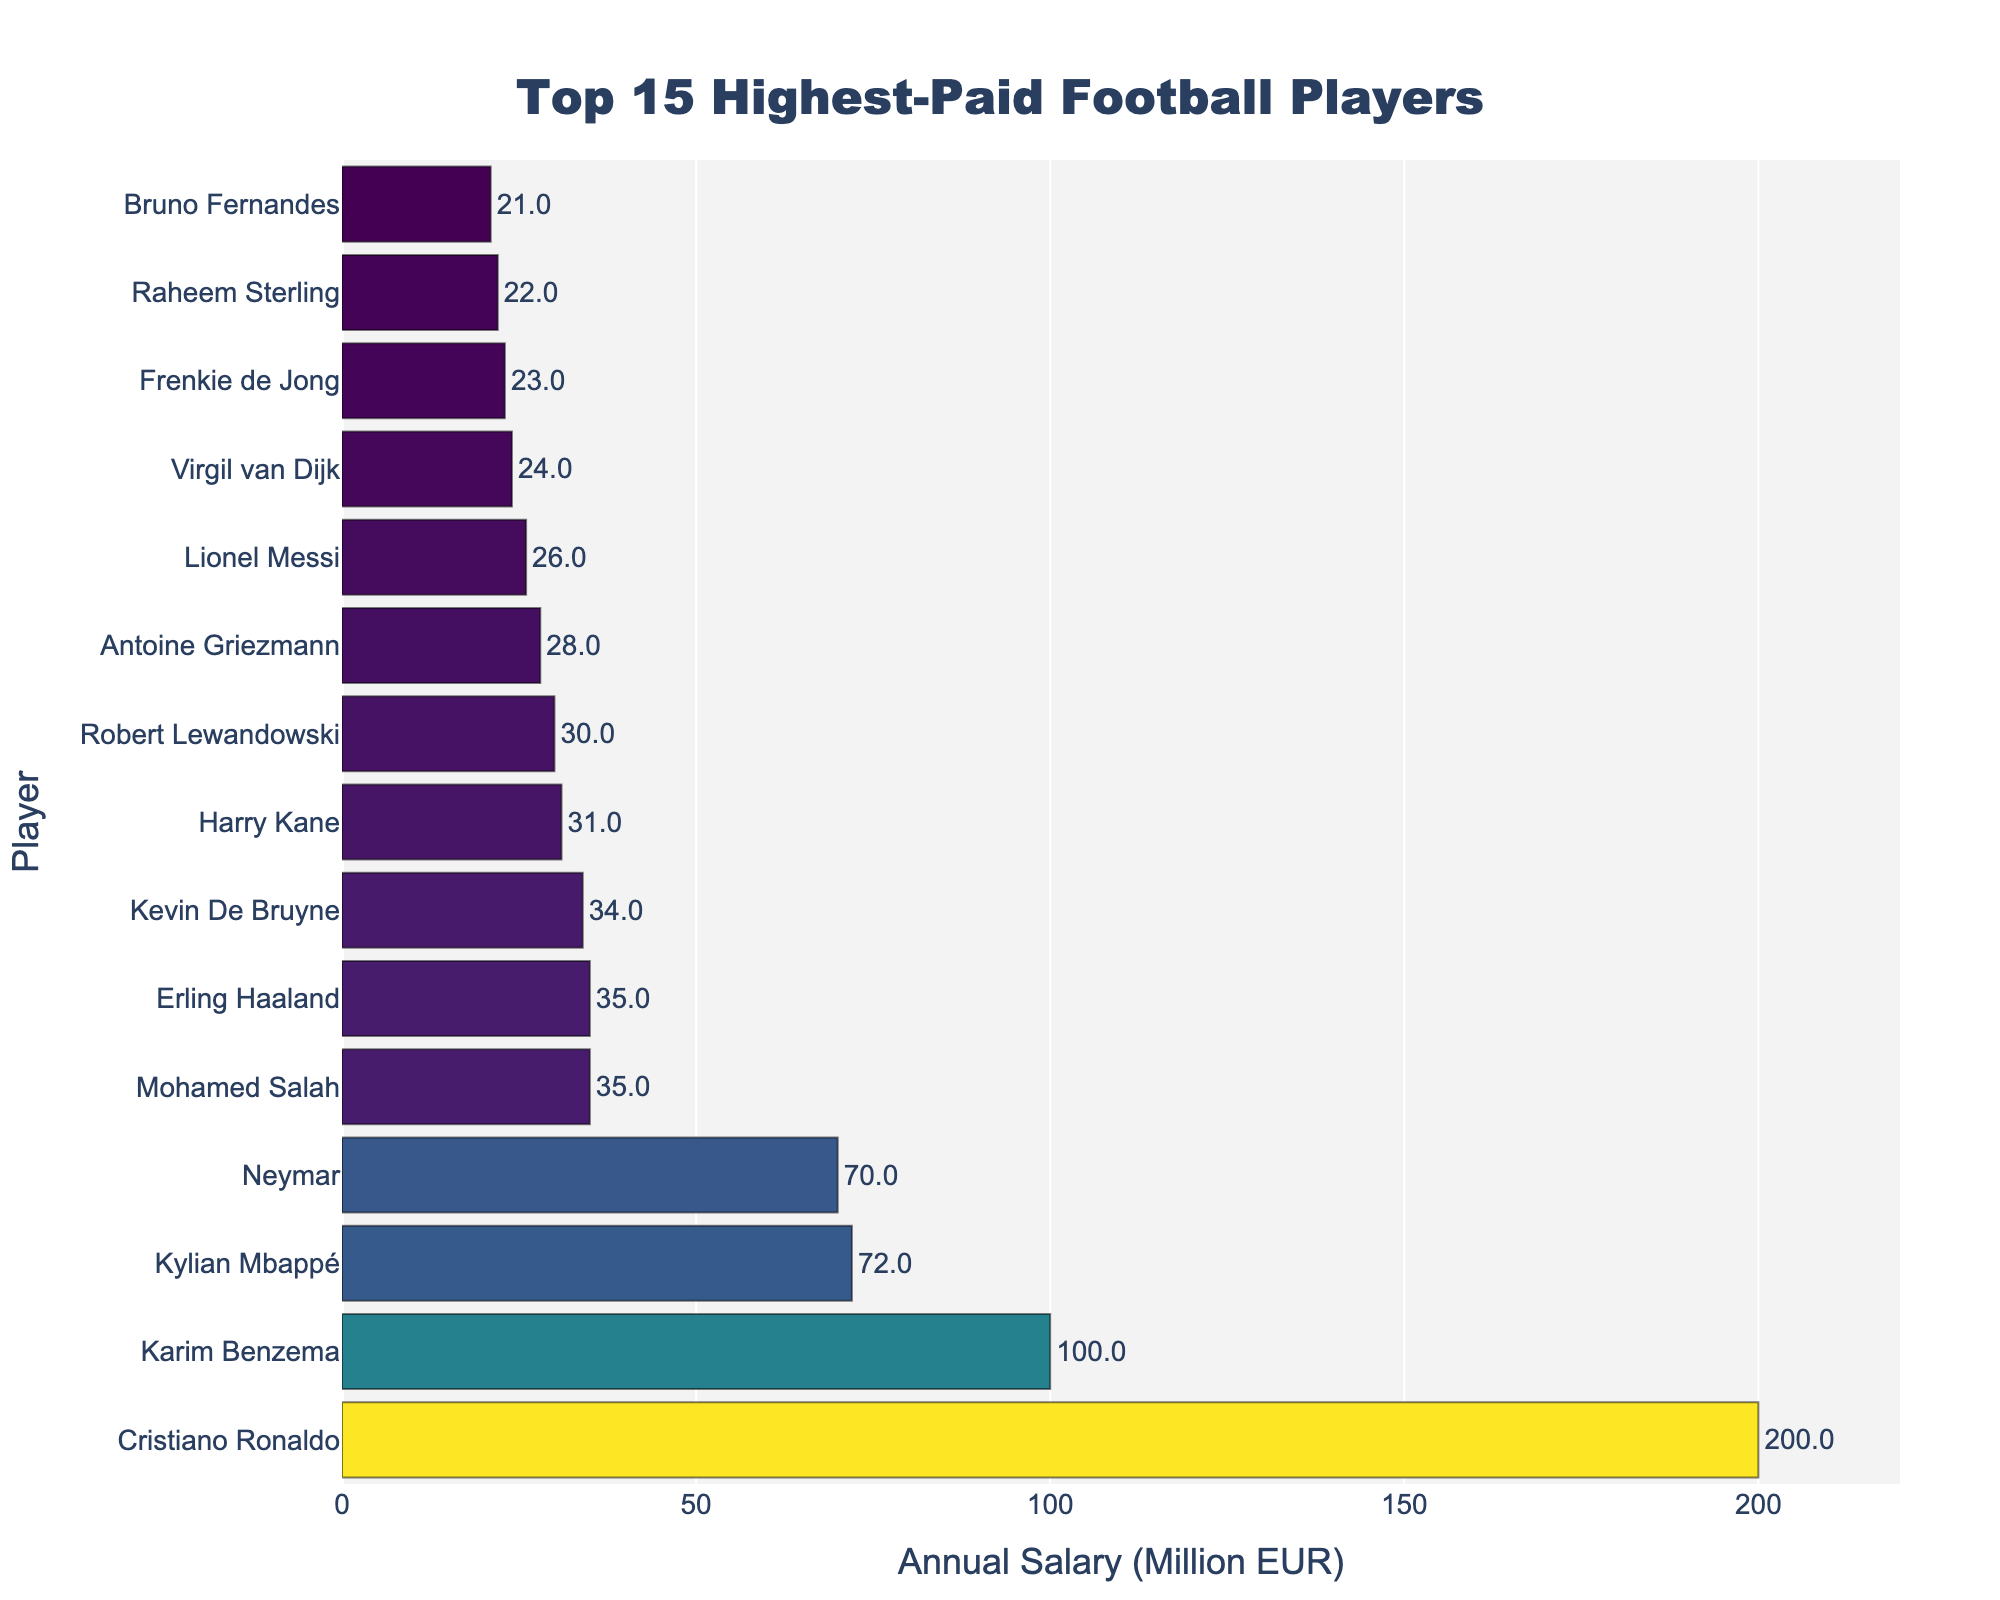Which player has the highest annual salary? The player with the highest bar in the chart represents the highest annual salary.
Answer: Cristiano Ronaldo How much more does Karim Benzema earn annually compared to Kylian Mbappé? Karim Benzema's annual salary is 100 million EUR, and Kylian Mbappé's is 72 million EUR. Subtract 72 from 100.
Answer: 28 million EUR What is the combined annual salary of the top 3 highest-paid players? The top 3 players are Cristiano Ronaldo (200 million EUR), Karim Benzema (100 million EUR), and Kylian Mbappé (72 million EUR). Sum their salaries: 200 + 100 + 72.
Answer: 372 million EUR Who earns more, Harry Kane or Robert Lewandowski? Compare the lengths of the bars for Harry Kane (31 million EUR) and Robert Lewandowski (30 million EUR).
Answer: Harry Kane What is the average annual salary of all listed players? Add the annual salaries of all players and divide by the number of players (15 players). Total sum: 200 + 100 + 72 + 70 + 35 + 35 + 34 + 31 + 30 + 28 + 26 + 24 + 23 + 22 + 21 = 751. Then divide by 15.
Answer: 50.07 million EUR Which player earns the least annually among the listed players? The player with the shortest bar represents the lowest annual salary.
Answer: Bruno Fernandes What's the difference between the highest and the lowest annual salaries? The highest salary is Cristiano Ronaldo's (200 million EUR) and the lowest is Bruno Fernandes' (21 million EUR). Subtract 21 from 200.
Answer: 179 million EUR How many players earn more than 50 million EUR annually? Identify players with bars extending beyond the 50 million EUR mark. There are: Cristiano Ronaldo, Karim Benzema, Kylian Mbappé, and Neymar, which are 4 players.
Answer: 4 What is the median annual salary of the listed players? Sort the salaries and find the middle value. Sorted salaries: 21, 22, 23, 24, 26, 28, 30, 31, 34, 35, 35, 70, 72, 100, 200. The median is the 8th value.
Answer: 31 million EUR How does Mohamed Salah's salary compare to Erling Haaland's? Compare the lengths of their bars. Both Mohamed Salah and Erling Haaland have bars at 35 million EUR.
Answer: They are equal 